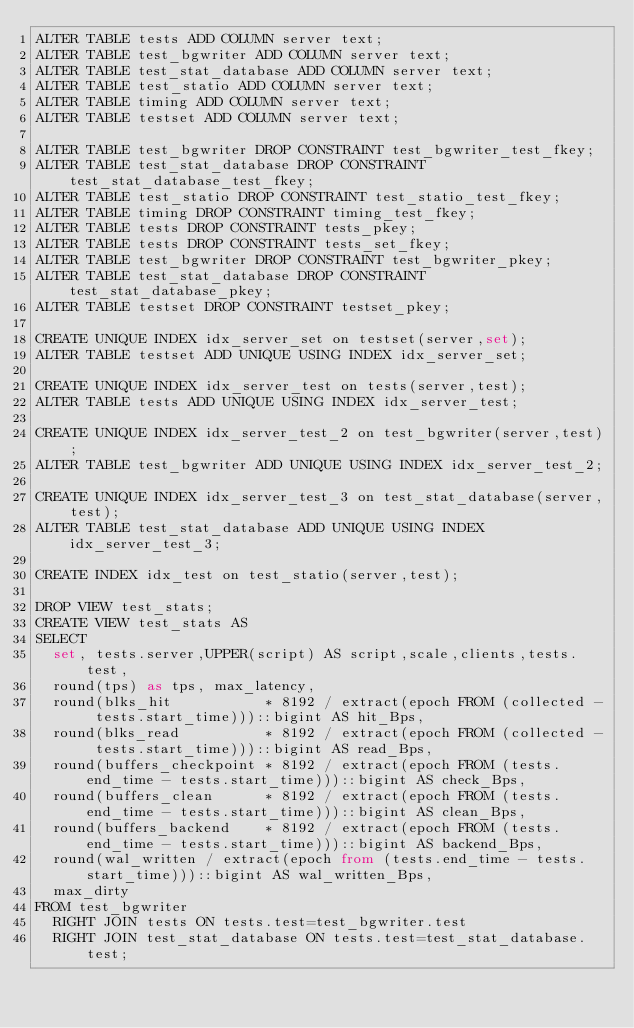Convert code to text. <code><loc_0><loc_0><loc_500><loc_500><_SQL_>ALTER TABLE tests ADD COLUMN server text;
ALTER TABLE test_bgwriter ADD COLUMN server text;
ALTER TABLE test_stat_database ADD COLUMN server text;
ALTER TABLE test_statio ADD COLUMN server text;
ALTER TABLE timing ADD COLUMN server text;
ALTER TABLE testset ADD COLUMN server text;

ALTER TABLE test_bgwriter DROP CONSTRAINT test_bgwriter_test_fkey;
ALTER TABLE test_stat_database DROP CONSTRAINT test_stat_database_test_fkey;
ALTER TABLE test_statio DROP CONSTRAINT test_statio_test_fkey;
ALTER TABLE timing DROP CONSTRAINT timing_test_fkey;
ALTER TABLE tests DROP CONSTRAINT tests_pkey;
ALTER TABLE tests DROP CONSTRAINT tests_set_fkey;
ALTER TABLE test_bgwriter DROP CONSTRAINT test_bgwriter_pkey;
ALTER TABLE test_stat_database DROP CONSTRAINT test_stat_database_pkey;
ALTER TABLE testset DROP CONSTRAINT testset_pkey;

CREATE UNIQUE INDEX idx_server_set on testset(server,set);
ALTER TABLE testset ADD UNIQUE USING INDEX idx_server_set;

CREATE UNIQUE INDEX idx_server_test on tests(server,test);
ALTER TABLE tests ADD UNIQUE USING INDEX idx_server_test;

CREATE UNIQUE INDEX idx_server_test_2 on test_bgwriter(server,test);
ALTER TABLE test_bgwriter ADD UNIQUE USING INDEX idx_server_test_2;

CREATE UNIQUE INDEX idx_server_test_3 on test_stat_database(server,test);
ALTER TABLE test_stat_database ADD UNIQUE USING INDEX idx_server_test_3;

CREATE INDEX idx_test on test_statio(server,test);

DROP VIEW test_stats;
CREATE VIEW test_stats AS
SELECT
  set, tests.server,UPPER(script) AS script,scale,clients,tests.test,
  round(tps) as tps, max_latency,
  round(blks_hit           * 8192 / extract(epoch FROM (collected - tests.start_time)))::bigint AS hit_Bps,
  round(blks_read          * 8192 / extract(epoch FROM (collected - tests.start_time)))::bigint AS read_Bps,
  round(buffers_checkpoint * 8192 / extract(epoch FROM (tests.end_time - tests.start_time)))::bigint AS check_Bps,
  round(buffers_clean      * 8192 / extract(epoch FROM (tests.end_time - tests.start_time)))::bigint AS clean_Bps,
  round(buffers_backend    * 8192 / extract(epoch FROM (tests.end_time - tests.start_time)))::bigint AS backend_Bps,
  round(wal_written / extract(epoch from (tests.end_time - tests.start_time)))::bigint AS wal_written_Bps,
  max_dirty
FROM test_bgwriter
  RIGHT JOIN tests ON tests.test=test_bgwriter.test
  RIGHT JOIN test_stat_database ON tests.test=test_stat_database.test;
</code> 